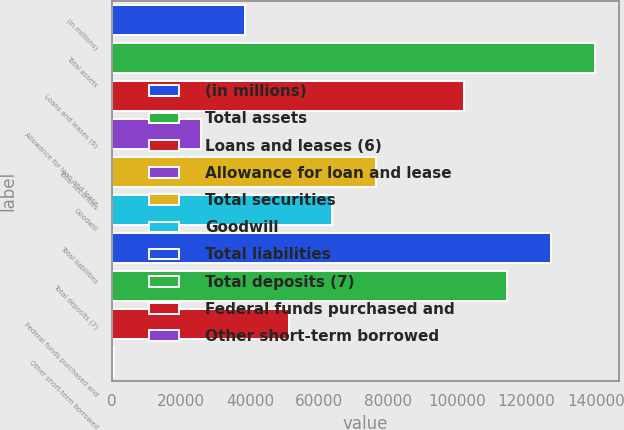<chart> <loc_0><loc_0><loc_500><loc_500><bar_chart><fcel>(in millions)<fcel>Total assets<fcel>Loans and leases (6)<fcel>Allowance for loan and lease<fcel>Total securities<fcel>Goodwill<fcel>Total liabilities<fcel>Total deposits (7)<fcel>Federal funds purchased and<fcel>Other short-term borrowed<nl><fcel>38466.6<fcel>139708<fcel>101743<fcel>25811.4<fcel>76432.2<fcel>63777<fcel>127053<fcel>114398<fcel>51121.8<fcel>501<nl></chart> 